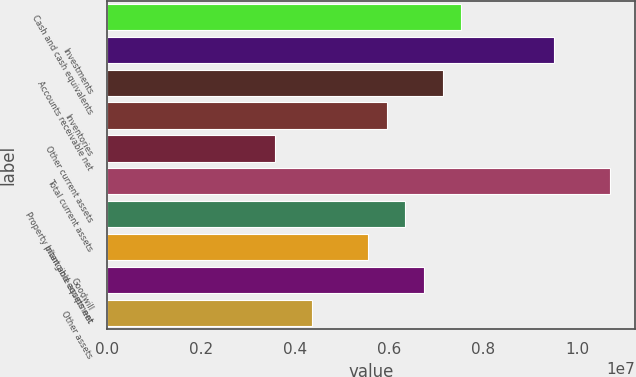Convert chart. <chart><loc_0><loc_0><loc_500><loc_500><bar_chart><fcel>Cash and cash equivalents<fcel>Investments<fcel>Accounts receivable net<fcel>Inventories<fcel>Other current assets<fcel>Total current assets<fcel>Property plant and equipment<fcel>Intangible assets net<fcel>Goodwill<fcel>Other assets<nl><fcel>7.5281e+06<fcel>9.50877e+06<fcel>7.13197e+06<fcel>5.94356e+06<fcel>3.56676e+06<fcel>1.06972e+07<fcel>6.3397e+06<fcel>5.54743e+06<fcel>6.73583e+06<fcel>4.35903e+06<nl></chart> 